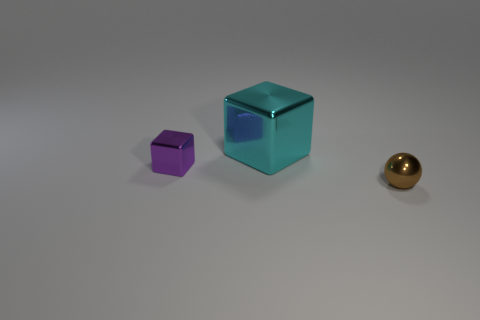Add 3 large cyan things. How many objects exist? 6 Subtract all blocks. How many objects are left? 1 Subtract 0 purple cylinders. How many objects are left? 3 Subtract all small gray matte cylinders. Subtract all shiny objects. How many objects are left? 0 Add 3 shiny cubes. How many shiny cubes are left? 5 Add 1 matte spheres. How many matte spheres exist? 1 